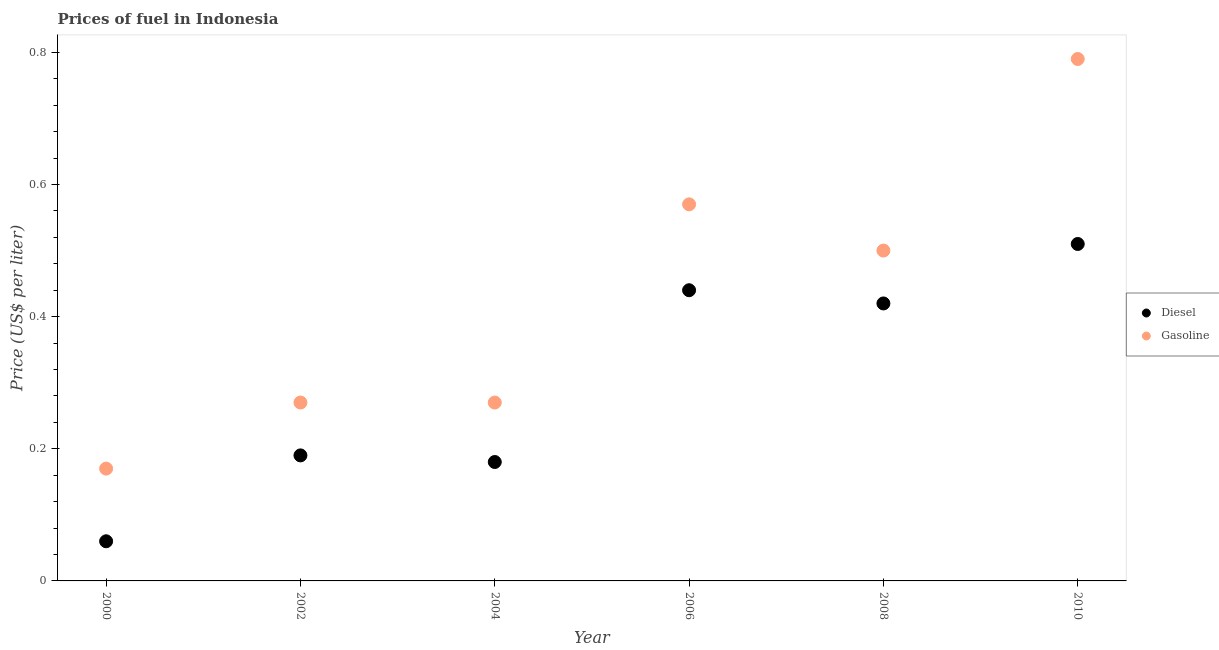How many different coloured dotlines are there?
Offer a very short reply. 2. Is the number of dotlines equal to the number of legend labels?
Your answer should be compact. Yes. What is the diesel price in 2008?
Your response must be concise. 0.42. Across all years, what is the maximum diesel price?
Offer a terse response. 0.51. Across all years, what is the minimum diesel price?
Offer a very short reply. 0.06. In which year was the diesel price maximum?
Give a very brief answer. 2010. In which year was the gasoline price minimum?
Offer a terse response. 2000. What is the total gasoline price in the graph?
Offer a very short reply. 2.57. What is the difference between the gasoline price in 2002 and that in 2006?
Provide a short and direct response. -0.3. What is the difference between the diesel price in 2002 and the gasoline price in 2008?
Your answer should be very brief. -0.31. In the year 2008, what is the difference between the gasoline price and diesel price?
Provide a short and direct response. 0.08. In how many years, is the diesel price greater than 0.48000000000000004 US$ per litre?
Give a very brief answer. 1. What is the ratio of the gasoline price in 2002 to that in 2008?
Offer a terse response. 0.54. What is the difference between the highest and the second highest diesel price?
Your response must be concise. 0.07. What is the difference between the highest and the lowest diesel price?
Offer a very short reply. 0.45. Does the gasoline price monotonically increase over the years?
Offer a very short reply. No. Is the gasoline price strictly less than the diesel price over the years?
Your answer should be very brief. No. How many dotlines are there?
Offer a terse response. 2. How many years are there in the graph?
Your answer should be very brief. 6. Where does the legend appear in the graph?
Your response must be concise. Center right. How many legend labels are there?
Ensure brevity in your answer.  2. What is the title of the graph?
Offer a very short reply. Prices of fuel in Indonesia. What is the label or title of the Y-axis?
Keep it short and to the point. Price (US$ per liter). What is the Price (US$ per liter) of Diesel in 2000?
Offer a terse response. 0.06. What is the Price (US$ per liter) in Gasoline in 2000?
Keep it short and to the point. 0.17. What is the Price (US$ per liter) in Diesel in 2002?
Your answer should be compact. 0.19. What is the Price (US$ per liter) in Gasoline in 2002?
Provide a short and direct response. 0.27. What is the Price (US$ per liter) in Diesel in 2004?
Provide a succinct answer. 0.18. What is the Price (US$ per liter) of Gasoline in 2004?
Provide a succinct answer. 0.27. What is the Price (US$ per liter) of Diesel in 2006?
Make the answer very short. 0.44. What is the Price (US$ per liter) in Gasoline in 2006?
Provide a succinct answer. 0.57. What is the Price (US$ per liter) in Diesel in 2008?
Your answer should be compact. 0.42. What is the Price (US$ per liter) of Diesel in 2010?
Offer a terse response. 0.51. What is the Price (US$ per liter) in Gasoline in 2010?
Offer a terse response. 0.79. Across all years, what is the maximum Price (US$ per liter) in Diesel?
Provide a succinct answer. 0.51. Across all years, what is the maximum Price (US$ per liter) in Gasoline?
Keep it short and to the point. 0.79. Across all years, what is the minimum Price (US$ per liter) of Diesel?
Ensure brevity in your answer.  0.06. Across all years, what is the minimum Price (US$ per liter) in Gasoline?
Provide a short and direct response. 0.17. What is the total Price (US$ per liter) in Gasoline in the graph?
Make the answer very short. 2.57. What is the difference between the Price (US$ per liter) of Diesel in 2000 and that in 2002?
Keep it short and to the point. -0.13. What is the difference between the Price (US$ per liter) of Diesel in 2000 and that in 2004?
Your response must be concise. -0.12. What is the difference between the Price (US$ per liter) in Gasoline in 2000 and that in 2004?
Your answer should be very brief. -0.1. What is the difference between the Price (US$ per liter) of Diesel in 2000 and that in 2006?
Your answer should be compact. -0.38. What is the difference between the Price (US$ per liter) of Diesel in 2000 and that in 2008?
Your response must be concise. -0.36. What is the difference between the Price (US$ per liter) in Gasoline in 2000 and that in 2008?
Ensure brevity in your answer.  -0.33. What is the difference between the Price (US$ per liter) of Diesel in 2000 and that in 2010?
Keep it short and to the point. -0.45. What is the difference between the Price (US$ per liter) of Gasoline in 2000 and that in 2010?
Keep it short and to the point. -0.62. What is the difference between the Price (US$ per liter) of Diesel in 2002 and that in 2004?
Your answer should be compact. 0.01. What is the difference between the Price (US$ per liter) of Diesel in 2002 and that in 2006?
Your answer should be compact. -0.25. What is the difference between the Price (US$ per liter) in Gasoline in 2002 and that in 2006?
Provide a succinct answer. -0.3. What is the difference between the Price (US$ per liter) in Diesel in 2002 and that in 2008?
Offer a very short reply. -0.23. What is the difference between the Price (US$ per liter) in Gasoline in 2002 and that in 2008?
Make the answer very short. -0.23. What is the difference between the Price (US$ per liter) of Diesel in 2002 and that in 2010?
Ensure brevity in your answer.  -0.32. What is the difference between the Price (US$ per liter) in Gasoline in 2002 and that in 2010?
Give a very brief answer. -0.52. What is the difference between the Price (US$ per liter) of Diesel in 2004 and that in 2006?
Keep it short and to the point. -0.26. What is the difference between the Price (US$ per liter) in Diesel in 2004 and that in 2008?
Your answer should be very brief. -0.24. What is the difference between the Price (US$ per liter) in Gasoline in 2004 and that in 2008?
Offer a terse response. -0.23. What is the difference between the Price (US$ per liter) in Diesel in 2004 and that in 2010?
Ensure brevity in your answer.  -0.33. What is the difference between the Price (US$ per liter) of Gasoline in 2004 and that in 2010?
Your response must be concise. -0.52. What is the difference between the Price (US$ per liter) in Diesel in 2006 and that in 2008?
Offer a terse response. 0.02. What is the difference between the Price (US$ per liter) in Gasoline in 2006 and that in 2008?
Offer a terse response. 0.07. What is the difference between the Price (US$ per liter) in Diesel in 2006 and that in 2010?
Ensure brevity in your answer.  -0.07. What is the difference between the Price (US$ per liter) in Gasoline in 2006 and that in 2010?
Your answer should be very brief. -0.22. What is the difference between the Price (US$ per liter) of Diesel in 2008 and that in 2010?
Your response must be concise. -0.09. What is the difference between the Price (US$ per liter) of Gasoline in 2008 and that in 2010?
Give a very brief answer. -0.29. What is the difference between the Price (US$ per liter) of Diesel in 2000 and the Price (US$ per liter) of Gasoline in 2002?
Keep it short and to the point. -0.21. What is the difference between the Price (US$ per liter) in Diesel in 2000 and the Price (US$ per liter) in Gasoline in 2004?
Ensure brevity in your answer.  -0.21. What is the difference between the Price (US$ per liter) in Diesel in 2000 and the Price (US$ per liter) in Gasoline in 2006?
Provide a short and direct response. -0.51. What is the difference between the Price (US$ per liter) of Diesel in 2000 and the Price (US$ per liter) of Gasoline in 2008?
Your answer should be very brief. -0.44. What is the difference between the Price (US$ per liter) in Diesel in 2000 and the Price (US$ per liter) in Gasoline in 2010?
Make the answer very short. -0.73. What is the difference between the Price (US$ per liter) in Diesel in 2002 and the Price (US$ per liter) in Gasoline in 2004?
Provide a succinct answer. -0.08. What is the difference between the Price (US$ per liter) in Diesel in 2002 and the Price (US$ per liter) in Gasoline in 2006?
Your answer should be very brief. -0.38. What is the difference between the Price (US$ per liter) in Diesel in 2002 and the Price (US$ per liter) in Gasoline in 2008?
Your response must be concise. -0.31. What is the difference between the Price (US$ per liter) of Diesel in 2002 and the Price (US$ per liter) of Gasoline in 2010?
Give a very brief answer. -0.6. What is the difference between the Price (US$ per liter) in Diesel in 2004 and the Price (US$ per liter) in Gasoline in 2006?
Your answer should be very brief. -0.39. What is the difference between the Price (US$ per liter) in Diesel in 2004 and the Price (US$ per liter) in Gasoline in 2008?
Your answer should be compact. -0.32. What is the difference between the Price (US$ per liter) of Diesel in 2004 and the Price (US$ per liter) of Gasoline in 2010?
Offer a very short reply. -0.61. What is the difference between the Price (US$ per liter) in Diesel in 2006 and the Price (US$ per liter) in Gasoline in 2008?
Provide a succinct answer. -0.06. What is the difference between the Price (US$ per liter) of Diesel in 2006 and the Price (US$ per liter) of Gasoline in 2010?
Offer a very short reply. -0.35. What is the difference between the Price (US$ per liter) of Diesel in 2008 and the Price (US$ per liter) of Gasoline in 2010?
Ensure brevity in your answer.  -0.37. What is the average Price (US$ per liter) in Diesel per year?
Your response must be concise. 0.3. What is the average Price (US$ per liter) in Gasoline per year?
Offer a very short reply. 0.43. In the year 2000, what is the difference between the Price (US$ per liter) in Diesel and Price (US$ per liter) in Gasoline?
Provide a succinct answer. -0.11. In the year 2002, what is the difference between the Price (US$ per liter) in Diesel and Price (US$ per liter) in Gasoline?
Keep it short and to the point. -0.08. In the year 2004, what is the difference between the Price (US$ per liter) in Diesel and Price (US$ per liter) in Gasoline?
Your response must be concise. -0.09. In the year 2006, what is the difference between the Price (US$ per liter) in Diesel and Price (US$ per liter) in Gasoline?
Keep it short and to the point. -0.13. In the year 2008, what is the difference between the Price (US$ per liter) in Diesel and Price (US$ per liter) in Gasoline?
Give a very brief answer. -0.08. In the year 2010, what is the difference between the Price (US$ per liter) of Diesel and Price (US$ per liter) of Gasoline?
Your answer should be very brief. -0.28. What is the ratio of the Price (US$ per liter) in Diesel in 2000 to that in 2002?
Offer a terse response. 0.32. What is the ratio of the Price (US$ per liter) in Gasoline in 2000 to that in 2002?
Provide a succinct answer. 0.63. What is the ratio of the Price (US$ per liter) of Gasoline in 2000 to that in 2004?
Your response must be concise. 0.63. What is the ratio of the Price (US$ per liter) of Diesel in 2000 to that in 2006?
Keep it short and to the point. 0.14. What is the ratio of the Price (US$ per liter) of Gasoline in 2000 to that in 2006?
Provide a succinct answer. 0.3. What is the ratio of the Price (US$ per liter) of Diesel in 2000 to that in 2008?
Your response must be concise. 0.14. What is the ratio of the Price (US$ per liter) in Gasoline in 2000 to that in 2008?
Offer a terse response. 0.34. What is the ratio of the Price (US$ per liter) of Diesel in 2000 to that in 2010?
Offer a very short reply. 0.12. What is the ratio of the Price (US$ per liter) of Gasoline in 2000 to that in 2010?
Your answer should be very brief. 0.22. What is the ratio of the Price (US$ per liter) in Diesel in 2002 to that in 2004?
Your response must be concise. 1.06. What is the ratio of the Price (US$ per liter) of Gasoline in 2002 to that in 2004?
Ensure brevity in your answer.  1. What is the ratio of the Price (US$ per liter) in Diesel in 2002 to that in 2006?
Give a very brief answer. 0.43. What is the ratio of the Price (US$ per liter) in Gasoline in 2002 to that in 2006?
Your answer should be compact. 0.47. What is the ratio of the Price (US$ per liter) of Diesel in 2002 to that in 2008?
Keep it short and to the point. 0.45. What is the ratio of the Price (US$ per liter) in Gasoline in 2002 to that in 2008?
Your response must be concise. 0.54. What is the ratio of the Price (US$ per liter) of Diesel in 2002 to that in 2010?
Provide a short and direct response. 0.37. What is the ratio of the Price (US$ per liter) of Gasoline in 2002 to that in 2010?
Give a very brief answer. 0.34. What is the ratio of the Price (US$ per liter) in Diesel in 2004 to that in 2006?
Keep it short and to the point. 0.41. What is the ratio of the Price (US$ per liter) in Gasoline in 2004 to that in 2006?
Give a very brief answer. 0.47. What is the ratio of the Price (US$ per liter) of Diesel in 2004 to that in 2008?
Offer a very short reply. 0.43. What is the ratio of the Price (US$ per liter) in Gasoline in 2004 to that in 2008?
Your response must be concise. 0.54. What is the ratio of the Price (US$ per liter) of Diesel in 2004 to that in 2010?
Offer a very short reply. 0.35. What is the ratio of the Price (US$ per liter) in Gasoline in 2004 to that in 2010?
Offer a terse response. 0.34. What is the ratio of the Price (US$ per liter) in Diesel in 2006 to that in 2008?
Keep it short and to the point. 1.05. What is the ratio of the Price (US$ per liter) in Gasoline in 2006 to that in 2008?
Make the answer very short. 1.14. What is the ratio of the Price (US$ per liter) in Diesel in 2006 to that in 2010?
Your answer should be compact. 0.86. What is the ratio of the Price (US$ per liter) in Gasoline in 2006 to that in 2010?
Your answer should be compact. 0.72. What is the ratio of the Price (US$ per liter) of Diesel in 2008 to that in 2010?
Provide a short and direct response. 0.82. What is the ratio of the Price (US$ per liter) in Gasoline in 2008 to that in 2010?
Make the answer very short. 0.63. What is the difference between the highest and the second highest Price (US$ per liter) in Diesel?
Your answer should be compact. 0.07. What is the difference between the highest and the second highest Price (US$ per liter) of Gasoline?
Your answer should be very brief. 0.22. What is the difference between the highest and the lowest Price (US$ per liter) of Diesel?
Provide a short and direct response. 0.45. What is the difference between the highest and the lowest Price (US$ per liter) in Gasoline?
Provide a succinct answer. 0.62. 